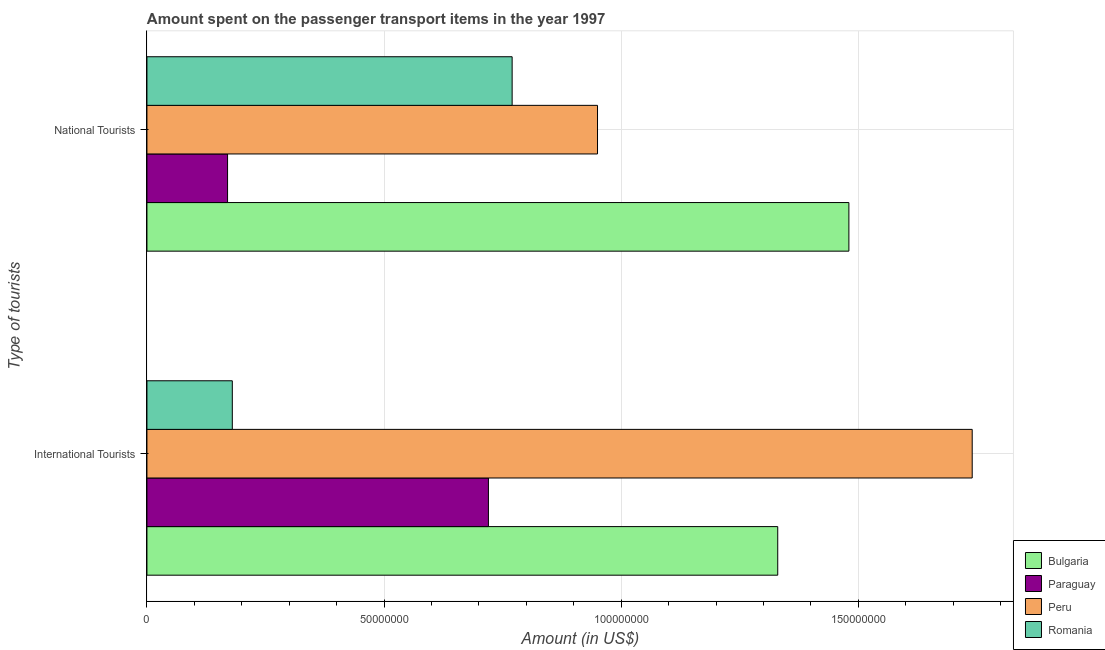How many bars are there on the 1st tick from the bottom?
Your answer should be very brief. 4. What is the label of the 2nd group of bars from the top?
Keep it short and to the point. International Tourists. What is the amount spent on transport items of international tourists in Peru?
Offer a terse response. 1.74e+08. Across all countries, what is the maximum amount spent on transport items of national tourists?
Keep it short and to the point. 1.48e+08. Across all countries, what is the minimum amount spent on transport items of national tourists?
Ensure brevity in your answer.  1.70e+07. In which country was the amount spent on transport items of international tourists maximum?
Your answer should be very brief. Peru. In which country was the amount spent on transport items of national tourists minimum?
Provide a succinct answer. Paraguay. What is the total amount spent on transport items of national tourists in the graph?
Provide a succinct answer. 3.37e+08. What is the difference between the amount spent on transport items of international tourists in Paraguay and that in Romania?
Keep it short and to the point. 5.40e+07. What is the difference between the amount spent on transport items of national tourists in Peru and the amount spent on transport items of international tourists in Romania?
Keep it short and to the point. 7.70e+07. What is the average amount spent on transport items of international tourists per country?
Make the answer very short. 9.92e+07. What is the difference between the amount spent on transport items of national tourists and amount spent on transport items of international tourists in Paraguay?
Your response must be concise. -5.50e+07. In how many countries, is the amount spent on transport items of national tourists greater than 20000000 US$?
Keep it short and to the point. 3. What is the ratio of the amount spent on transport items of international tourists in Paraguay to that in Peru?
Offer a terse response. 0.41. Is the amount spent on transport items of national tourists in Paraguay less than that in Peru?
Ensure brevity in your answer.  Yes. What does the 1st bar from the top in National Tourists represents?
Provide a succinct answer. Romania. Are all the bars in the graph horizontal?
Ensure brevity in your answer.  Yes. How many countries are there in the graph?
Provide a short and direct response. 4. What is the difference between two consecutive major ticks on the X-axis?
Give a very brief answer. 5.00e+07. Are the values on the major ticks of X-axis written in scientific E-notation?
Keep it short and to the point. No. Does the graph contain any zero values?
Keep it short and to the point. No. Does the graph contain grids?
Offer a very short reply. Yes. How many legend labels are there?
Provide a short and direct response. 4. What is the title of the graph?
Your answer should be very brief. Amount spent on the passenger transport items in the year 1997. What is the label or title of the Y-axis?
Make the answer very short. Type of tourists. What is the Amount (in US$) of Bulgaria in International Tourists?
Make the answer very short. 1.33e+08. What is the Amount (in US$) in Paraguay in International Tourists?
Provide a short and direct response. 7.20e+07. What is the Amount (in US$) in Peru in International Tourists?
Your answer should be compact. 1.74e+08. What is the Amount (in US$) of Romania in International Tourists?
Provide a succinct answer. 1.80e+07. What is the Amount (in US$) of Bulgaria in National Tourists?
Provide a succinct answer. 1.48e+08. What is the Amount (in US$) in Paraguay in National Tourists?
Offer a terse response. 1.70e+07. What is the Amount (in US$) of Peru in National Tourists?
Provide a short and direct response. 9.50e+07. What is the Amount (in US$) in Romania in National Tourists?
Offer a very short reply. 7.70e+07. Across all Type of tourists, what is the maximum Amount (in US$) of Bulgaria?
Offer a terse response. 1.48e+08. Across all Type of tourists, what is the maximum Amount (in US$) of Paraguay?
Give a very brief answer. 7.20e+07. Across all Type of tourists, what is the maximum Amount (in US$) in Peru?
Offer a very short reply. 1.74e+08. Across all Type of tourists, what is the maximum Amount (in US$) in Romania?
Your answer should be compact. 7.70e+07. Across all Type of tourists, what is the minimum Amount (in US$) of Bulgaria?
Your response must be concise. 1.33e+08. Across all Type of tourists, what is the minimum Amount (in US$) in Paraguay?
Keep it short and to the point. 1.70e+07. Across all Type of tourists, what is the minimum Amount (in US$) in Peru?
Keep it short and to the point. 9.50e+07. Across all Type of tourists, what is the minimum Amount (in US$) in Romania?
Provide a succinct answer. 1.80e+07. What is the total Amount (in US$) in Bulgaria in the graph?
Offer a very short reply. 2.81e+08. What is the total Amount (in US$) in Paraguay in the graph?
Your answer should be very brief. 8.90e+07. What is the total Amount (in US$) of Peru in the graph?
Provide a short and direct response. 2.69e+08. What is the total Amount (in US$) in Romania in the graph?
Your answer should be very brief. 9.50e+07. What is the difference between the Amount (in US$) of Bulgaria in International Tourists and that in National Tourists?
Give a very brief answer. -1.50e+07. What is the difference between the Amount (in US$) of Paraguay in International Tourists and that in National Tourists?
Give a very brief answer. 5.50e+07. What is the difference between the Amount (in US$) in Peru in International Tourists and that in National Tourists?
Ensure brevity in your answer.  7.90e+07. What is the difference between the Amount (in US$) of Romania in International Tourists and that in National Tourists?
Keep it short and to the point. -5.90e+07. What is the difference between the Amount (in US$) of Bulgaria in International Tourists and the Amount (in US$) of Paraguay in National Tourists?
Your answer should be very brief. 1.16e+08. What is the difference between the Amount (in US$) of Bulgaria in International Tourists and the Amount (in US$) of Peru in National Tourists?
Make the answer very short. 3.80e+07. What is the difference between the Amount (in US$) of Bulgaria in International Tourists and the Amount (in US$) of Romania in National Tourists?
Provide a succinct answer. 5.60e+07. What is the difference between the Amount (in US$) of Paraguay in International Tourists and the Amount (in US$) of Peru in National Tourists?
Provide a short and direct response. -2.30e+07. What is the difference between the Amount (in US$) in Paraguay in International Tourists and the Amount (in US$) in Romania in National Tourists?
Give a very brief answer. -5.00e+06. What is the difference between the Amount (in US$) in Peru in International Tourists and the Amount (in US$) in Romania in National Tourists?
Make the answer very short. 9.70e+07. What is the average Amount (in US$) of Bulgaria per Type of tourists?
Provide a short and direct response. 1.40e+08. What is the average Amount (in US$) in Paraguay per Type of tourists?
Provide a succinct answer. 4.45e+07. What is the average Amount (in US$) in Peru per Type of tourists?
Keep it short and to the point. 1.34e+08. What is the average Amount (in US$) of Romania per Type of tourists?
Your response must be concise. 4.75e+07. What is the difference between the Amount (in US$) in Bulgaria and Amount (in US$) in Paraguay in International Tourists?
Provide a short and direct response. 6.10e+07. What is the difference between the Amount (in US$) of Bulgaria and Amount (in US$) of Peru in International Tourists?
Keep it short and to the point. -4.10e+07. What is the difference between the Amount (in US$) of Bulgaria and Amount (in US$) of Romania in International Tourists?
Offer a very short reply. 1.15e+08. What is the difference between the Amount (in US$) of Paraguay and Amount (in US$) of Peru in International Tourists?
Make the answer very short. -1.02e+08. What is the difference between the Amount (in US$) of Paraguay and Amount (in US$) of Romania in International Tourists?
Provide a short and direct response. 5.40e+07. What is the difference between the Amount (in US$) in Peru and Amount (in US$) in Romania in International Tourists?
Offer a terse response. 1.56e+08. What is the difference between the Amount (in US$) in Bulgaria and Amount (in US$) in Paraguay in National Tourists?
Keep it short and to the point. 1.31e+08. What is the difference between the Amount (in US$) in Bulgaria and Amount (in US$) in Peru in National Tourists?
Ensure brevity in your answer.  5.30e+07. What is the difference between the Amount (in US$) of Bulgaria and Amount (in US$) of Romania in National Tourists?
Offer a very short reply. 7.10e+07. What is the difference between the Amount (in US$) of Paraguay and Amount (in US$) of Peru in National Tourists?
Offer a terse response. -7.80e+07. What is the difference between the Amount (in US$) in Paraguay and Amount (in US$) in Romania in National Tourists?
Provide a succinct answer. -6.00e+07. What is the difference between the Amount (in US$) of Peru and Amount (in US$) of Romania in National Tourists?
Your answer should be very brief. 1.80e+07. What is the ratio of the Amount (in US$) in Bulgaria in International Tourists to that in National Tourists?
Ensure brevity in your answer.  0.9. What is the ratio of the Amount (in US$) in Paraguay in International Tourists to that in National Tourists?
Provide a short and direct response. 4.24. What is the ratio of the Amount (in US$) of Peru in International Tourists to that in National Tourists?
Your answer should be very brief. 1.83. What is the ratio of the Amount (in US$) in Romania in International Tourists to that in National Tourists?
Keep it short and to the point. 0.23. What is the difference between the highest and the second highest Amount (in US$) of Bulgaria?
Give a very brief answer. 1.50e+07. What is the difference between the highest and the second highest Amount (in US$) in Paraguay?
Provide a short and direct response. 5.50e+07. What is the difference between the highest and the second highest Amount (in US$) in Peru?
Your answer should be compact. 7.90e+07. What is the difference between the highest and the second highest Amount (in US$) of Romania?
Provide a short and direct response. 5.90e+07. What is the difference between the highest and the lowest Amount (in US$) of Bulgaria?
Provide a succinct answer. 1.50e+07. What is the difference between the highest and the lowest Amount (in US$) of Paraguay?
Make the answer very short. 5.50e+07. What is the difference between the highest and the lowest Amount (in US$) of Peru?
Keep it short and to the point. 7.90e+07. What is the difference between the highest and the lowest Amount (in US$) in Romania?
Your answer should be compact. 5.90e+07. 